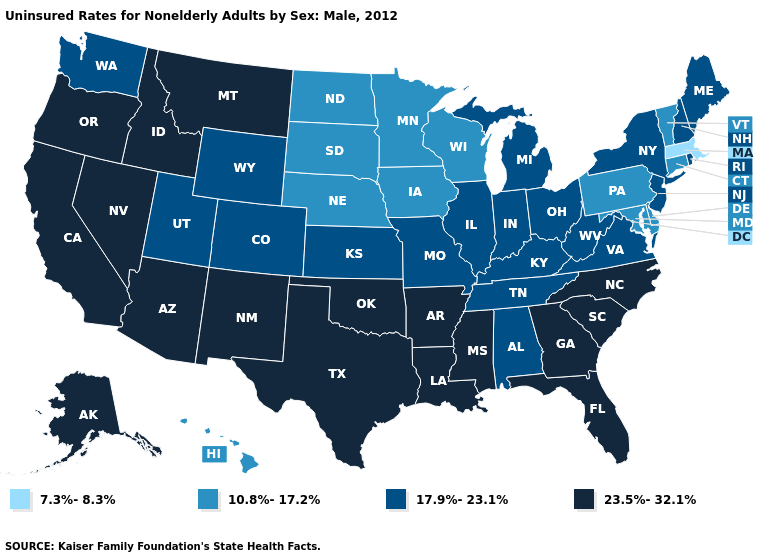What is the value of Washington?
Answer briefly. 17.9%-23.1%. What is the value of North Dakota?
Concise answer only. 10.8%-17.2%. Name the states that have a value in the range 17.9%-23.1%?
Be succinct. Alabama, Colorado, Illinois, Indiana, Kansas, Kentucky, Maine, Michigan, Missouri, New Hampshire, New Jersey, New York, Ohio, Rhode Island, Tennessee, Utah, Virginia, Washington, West Virginia, Wyoming. Which states have the highest value in the USA?
Answer briefly. Alaska, Arizona, Arkansas, California, Florida, Georgia, Idaho, Louisiana, Mississippi, Montana, Nevada, New Mexico, North Carolina, Oklahoma, Oregon, South Carolina, Texas. Name the states that have a value in the range 7.3%-8.3%?
Write a very short answer. Massachusetts. Does West Virginia have the lowest value in the USA?
Write a very short answer. No. Which states have the lowest value in the South?
Write a very short answer. Delaware, Maryland. Name the states that have a value in the range 17.9%-23.1%?
Write a very short answer. Alabama, Colorado, Illinois, Indiana, Kansas, Kentucky, Maine, Michigan, Missouri, New Hampshire, New Jersey, New York, Ohio, Rhode Island, Tennessee, Utah, Virginia, Washington, West Virginia, Wyoming. What is the value of Kansas?
Answer briefly. 17.9%-23.1%. What is the highest value in states that border Illinois?
Quick response, please. 17.9%-23.1%. Name the states that have a value in the range 7.3%-8.3%?
Answer briefly. Massachusetts. Which states hav the highest value in the West?
Write a very short answer. Alaska, Arizona, California, Idaho, Montana, Nevada, New Mexico, Oregon. Name the states that have a value in the range 7.3%-8.3%?
Give a very brief answer. Massachusetts. Which states hav the highest value in the Northeast?
Concise answer only. Maine, New Hampshire, New Jersey, New York, Rhode Island. Does the first symbol in the legend represent the smallest category?
Short answer required. Yes. 